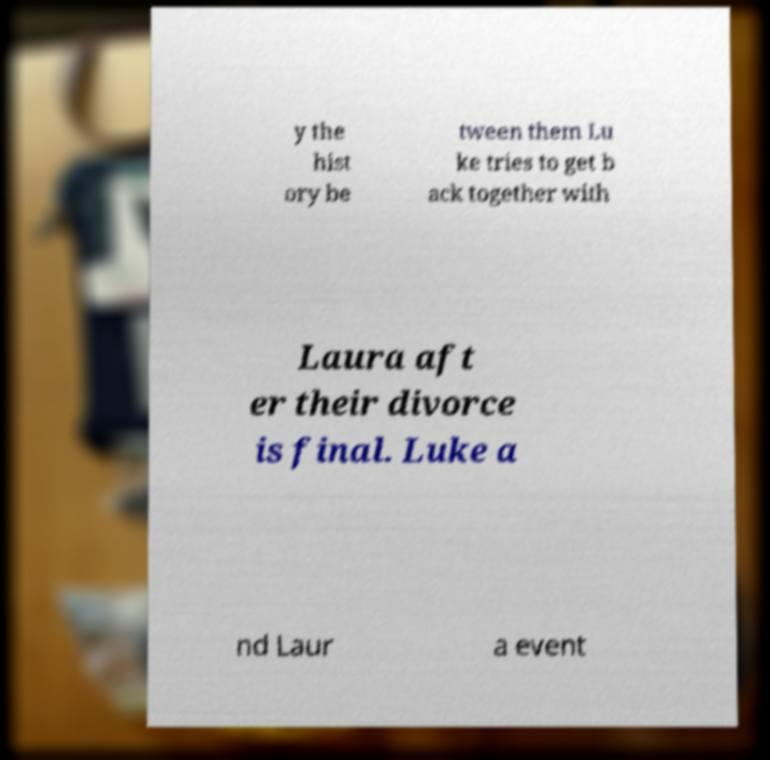Could you extract and type out the text from this image? y the hist ory be tween them Lu ke tries to get b ack together with Laura aft er their divorce is final. Luke a nd Laur a event 